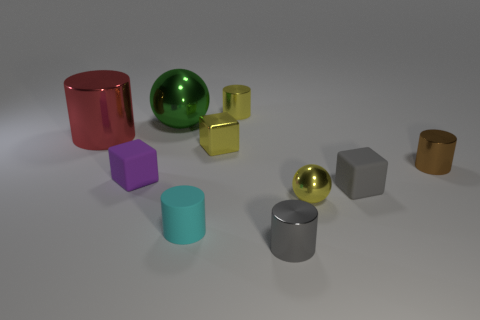How many other objects are the same color as the small metallic ball?
Provide a short and direct response. 2. Does the big metallic ball have the same color as the tiny shiny cube?
Provide a short and direct response. No. How many red rubber spheres are there?
Provide a short and direct response. 0. There is a thing that is to the left of the rubber block on the left side of the green thing; what is its material?
Make the answer very short. Metal. There is a ball that is the same size as the purple matte object; what is it made of?
Offer a terse response. Metal. Does the ball in front of the green ball have the same size as the purple thing?
Offer a terse response. Yes. There is a large object on the left side of the big green object; is its shape the same as the tiny brown metallic thing?
Keep it short and to the point. Yes. What number of things are either tiny cylinders or big shiny objects behind the big red metal object?
Your answer should be very brief. 5. Are there fewer metal objects than gray balls?
Your response must be concise. No. Are there more tiny yellow metallic blocks than gray rubber balls?
Provide a succinct answer. Yes. 